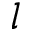Convert formula to latex. <formula><loc_0><loc_0><loc_500><loc_500>l</formula> 